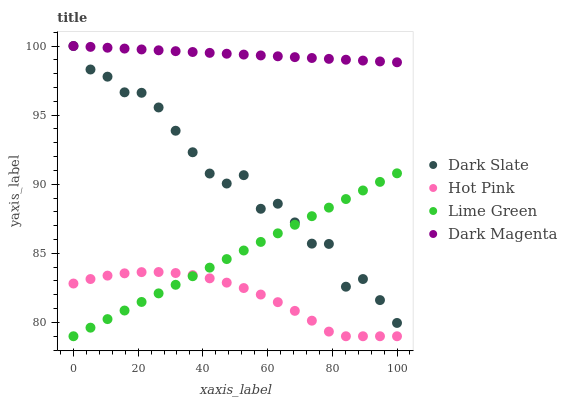Does Hot Pink have the minimum area under the curve?
Answer yes or no. Yes. Does Dark Magenta have the maximum area under the curve?
Answer yes or no. Yes. Does Lime Green have the minimum area under the curve?
Answer yes or no. No. Does Lime Green have the maximum area under the curve?
Answer yes or no. No. Is Dark Magenta the smoothest?
Answer yes or no. Yes. Is Dark Slate the roughest?
Answer yes or no. Yes. Is Hot Pink the smoothest?
Answer yes or no. No. Is Hot Pink the roughest?
Answer yes or no. No. Does Hot Pink have the lowest value?
Answer yes or no. Yes. Does Dark Magenta have the lowest value?
Answer yes or no. No. Does Dark Magenta have the highest value?
Answer yes or no. Yes. Does Lime Green have the highest value?
Answer yes or no. No. Is Hot Pink less than Dark Slate?
Answer yes or no. Yes. Is Dark Magenta greater than Lime Green?
Answer yes or no. Yes. Does Hot Pink intersect Lime Green?
Answer yes or no. Yes. Is Hot Pink less than Lime Green?
Answer yes or no. No. Is Hot Pink greater than Lime Green?
Answer yes or no. No. Does Hot Pink intersect Dark Slate?
Answer yes or no. No. 